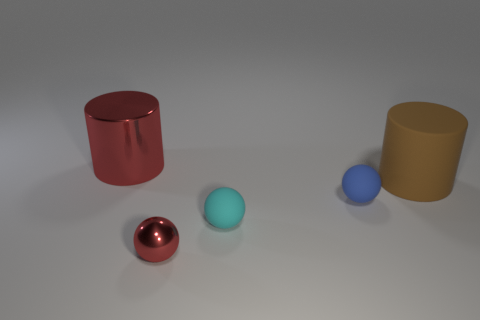Add 1 big red metallic objects. How many objects exist? 6 Subtract all spheres. How many objects are left? 2 Add 3 small rubber spheres. How many small rubber spheres are left? 5 Add 1 tiny green matte balls. How many tiny green matte balls exist? 1 Subtract 0 blue cubes. How many objects are left? 5 Subtract all cyan objects. Subtract all small things. How many objects are left? 1 